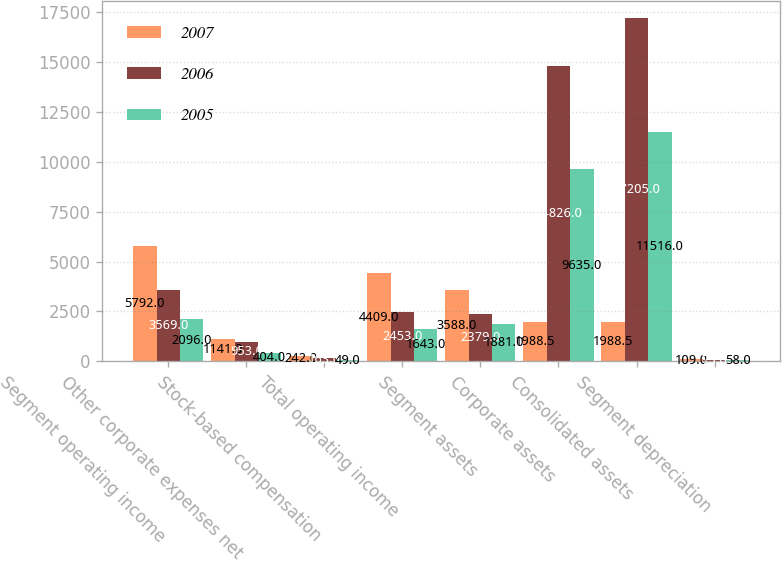<chart> <loc_0><loc_0><loc_500><loc_500><stacked_bar_chart><ecel><fcel>Segment operating income<fcel>Other corporate expenses net<fcel>Stock-based compensation<fcel>Total operating income<fcel>Segment assets<fcel>Corporate assets<fcel>Consolidated assets<fcel>Segment depreciation<nl><fcel>2007<fcel>5792<fcel>1141<fcel>242<fcel>4409<fcel>3588<fcel>1988.5<fcel>1988.5<fcel>109<nl><fcel>2006<fcel>3569<fcel>953<fcel>163<fcel>2453<fcel>2379<fcel>14826<fcel>17205<fcel>75<nl><fcel>2005<fcel>2096<fcel>404<fcel>49<fcel>1643<fcel>1881<fcel>9635<fcel>11516<fcel>58<nl></chart> 